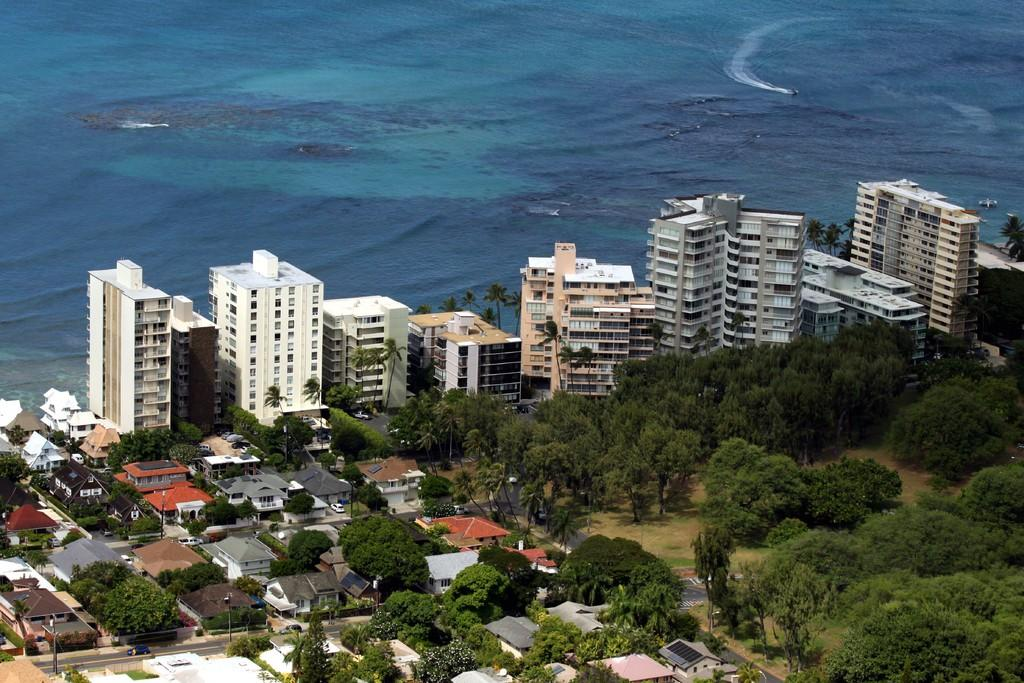What type of vegetation is present in the image? There are green color trees in the image. What structures can be seen in the image? There are homes and buildings in the image. What natural feature is visible in the image? There is a sea in the image. What color is the water in the image? The water in the image is blue-colored. What is the weight of the crown on the king's head in the image? There is no king or crown present in the image. What caption is written on the image? The image does not have a caption; it is a visual representation without any accompanying text. 